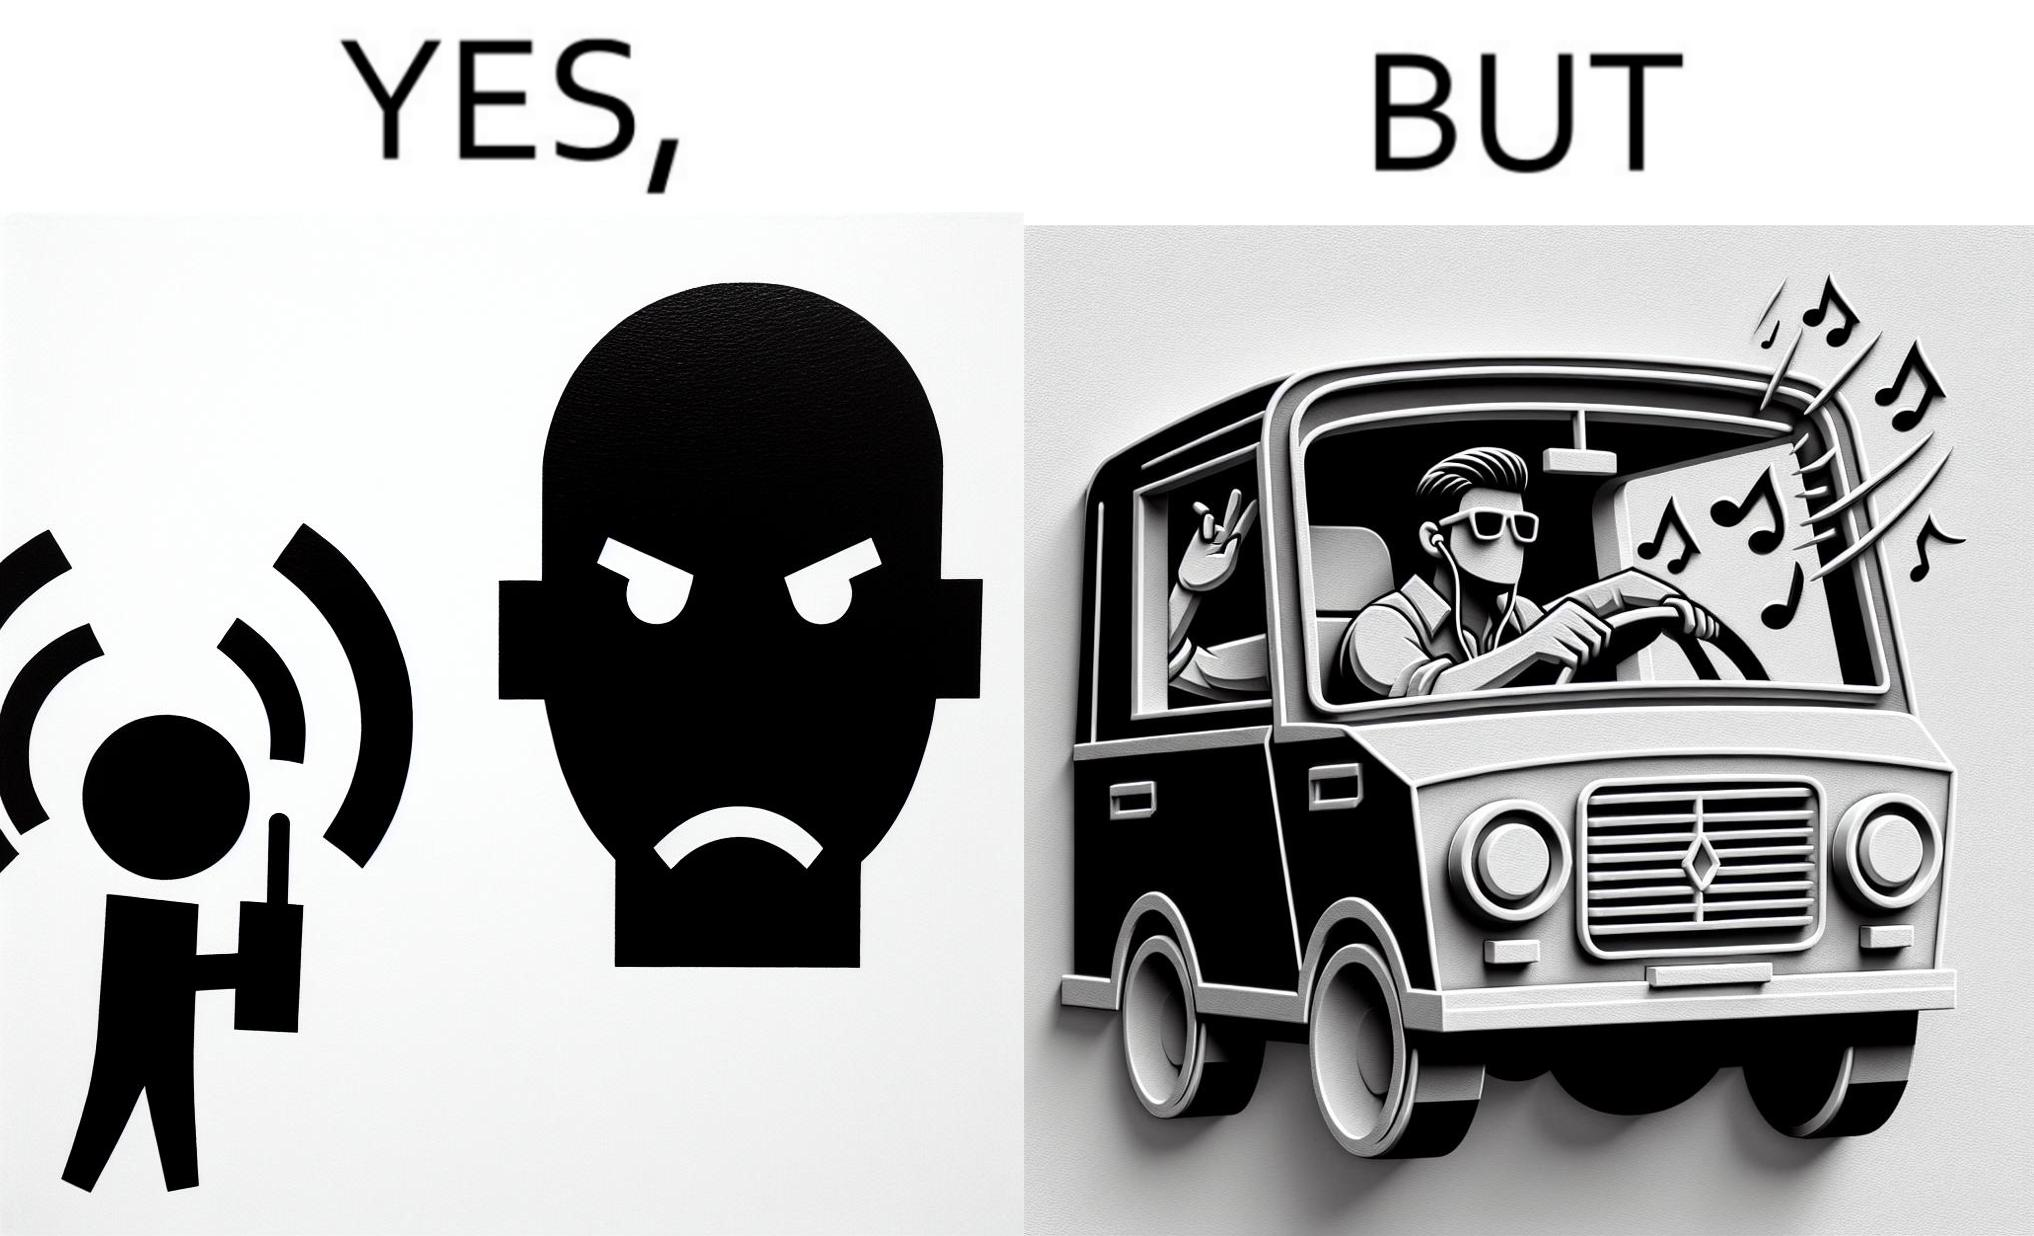Describe what you see in the left and right parts of this image. In the left part of the image: The image shows a boy playing music on his phone loudly. The image also shows another man annoyed by the loud music. In the right part of the image: The image shows a man driving a car with the windows of the car rolled down. He has one of his hands on the steering wheel and the other hand hanging out of the window of the driver side of the car. The man is playing loud music in his car with the sound coming out of the car. 